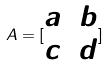Convert formula to latex. <formula><loc_0><loc_0><loc_500><loc_500>A = [ \begin{matrix} a & b \\ c & d \end{matrix} ]</formula> 